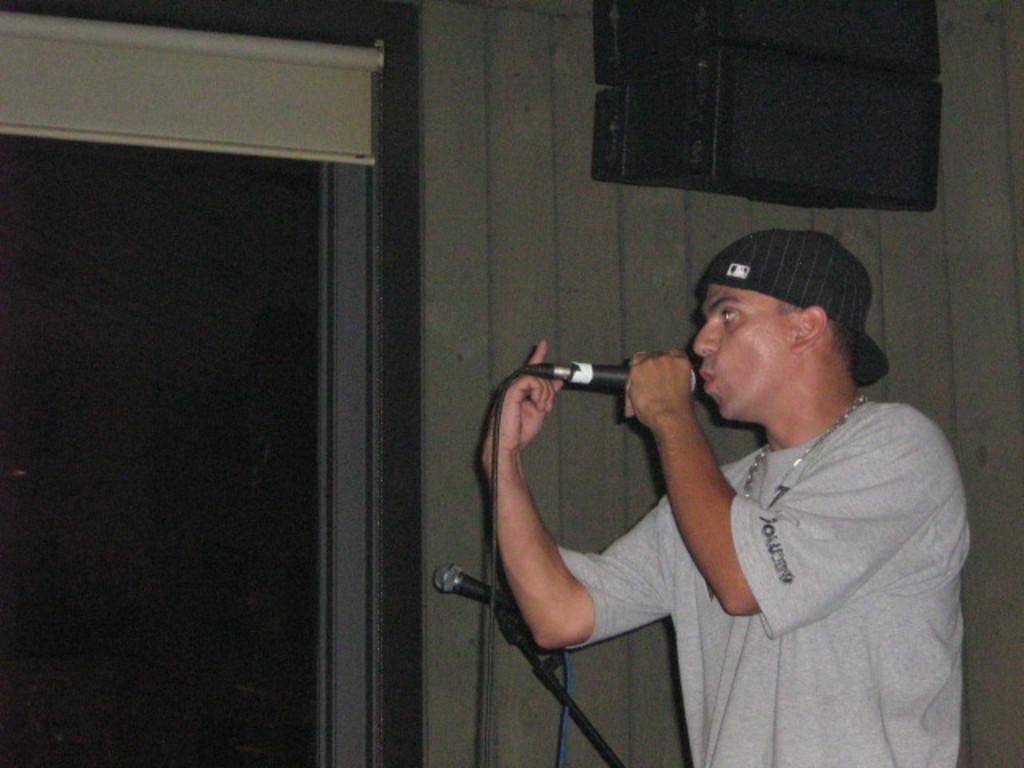What is the main subject of the image? The main subject of the image is a man. What is the man wearing? The man is wearing a grey T-shirt and a cap. What is the man holding in his hand? The man is holding a mic in his hand. What can be seen in the background of the image? There is a wall in the background of the image, and there is a door in the wall. What type of cabbage is hanging from the door in the image? There is no cabbage present in the image, and nothing is hanging from the door. Can you hear a bell ringing in the image? There is no bell present in the image, and no sound can be heard from the image. 